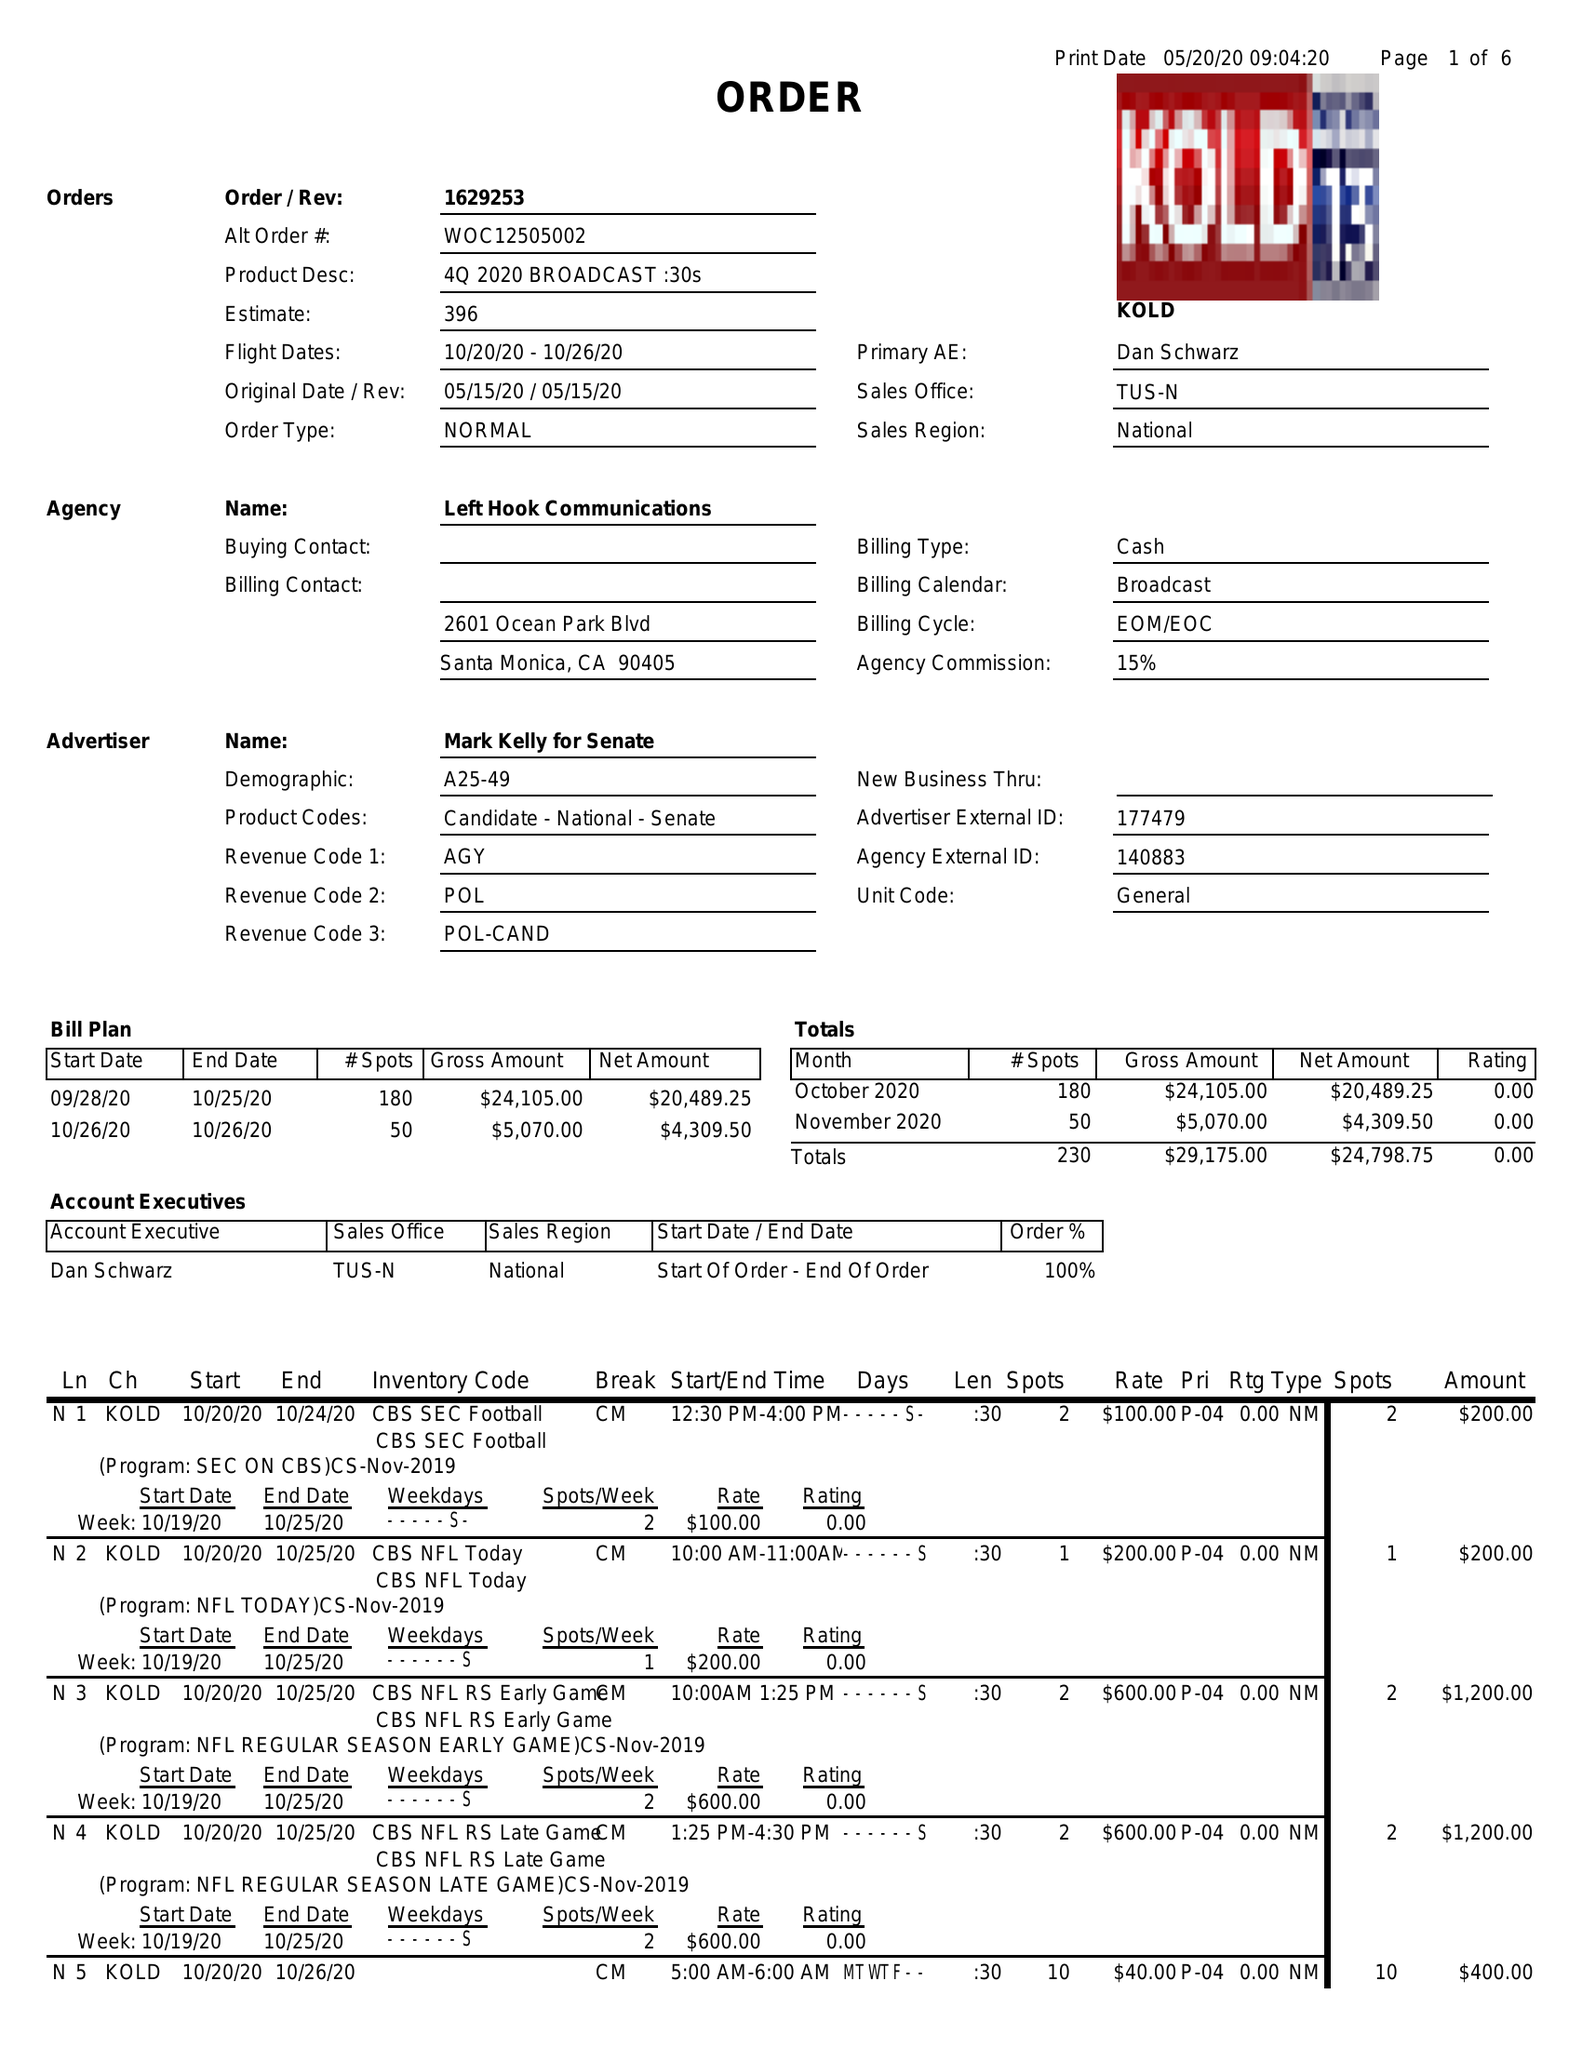What is the value for the contract_num?
Answer the question using a single word or phrase. 1629253 